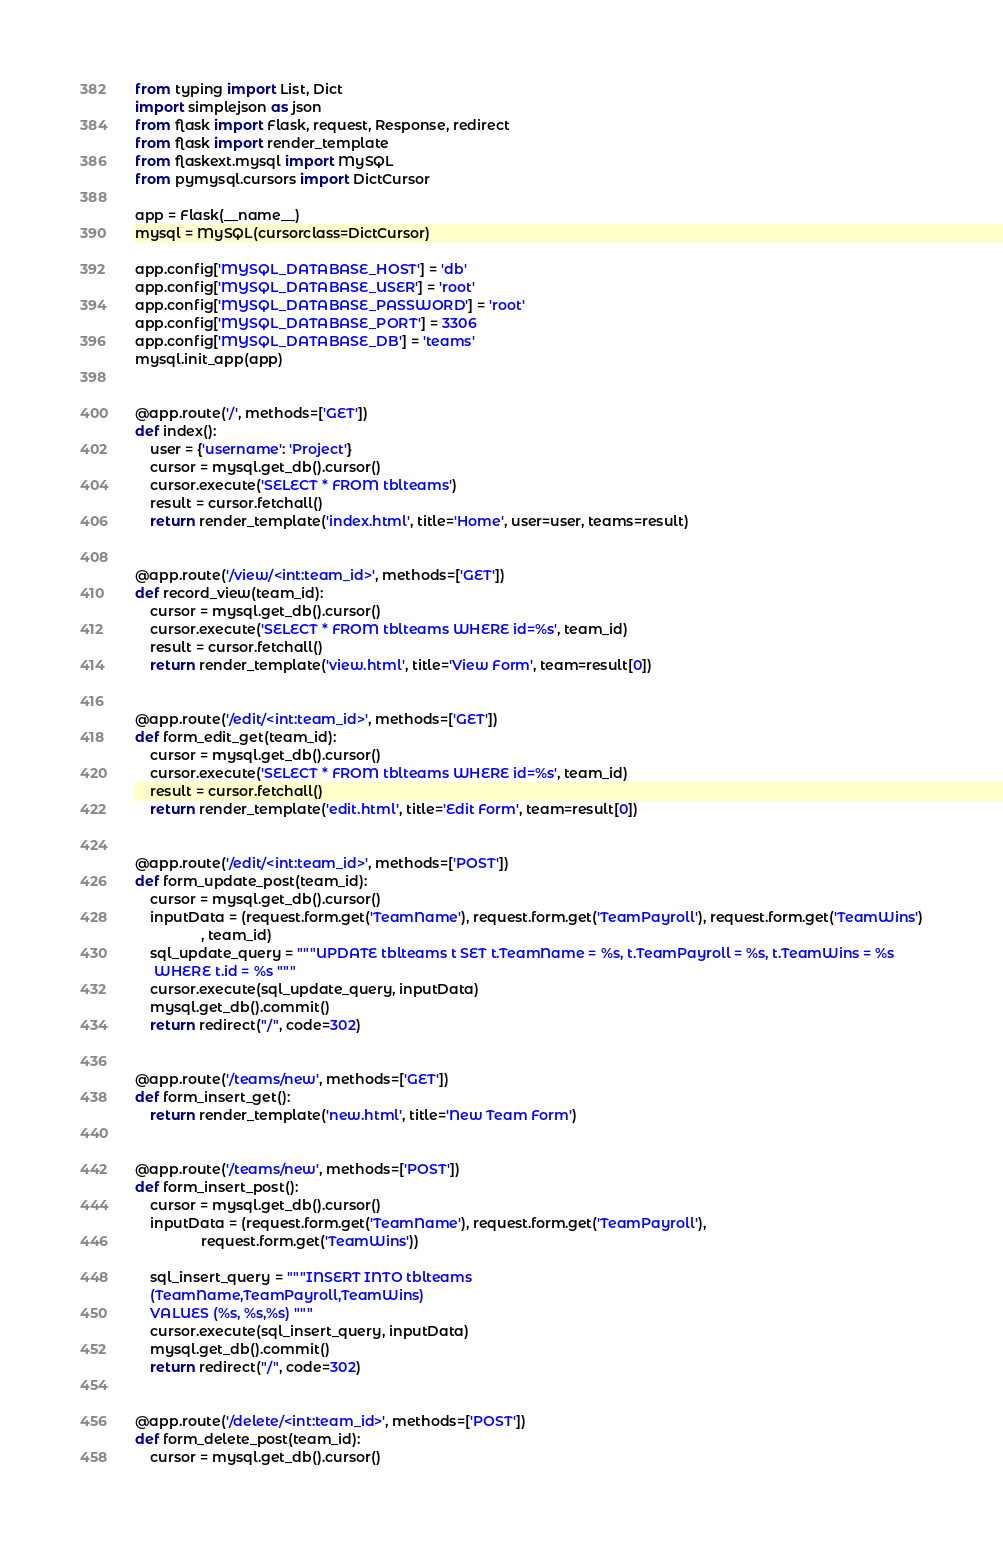Convert code to text. <code><loc_0><loc_0><loc_500><loc_500><_Python_>from typing import List, Dict
import simplejson as json
from flask import Flask, request, Response, redirect
from flask import render_template
from flaskext.mysql import MySQL
from pymysql.cursors import DictCursor

app = Flask(__name__)
mysql = MySQL(cursorclass=DictCursor)

app.config['MYSQL_DATABASE_HOST'] = 'db'
app.config['MYSQL_DATABASE_USER'] = 'root'
app.config['MYSQL_DATABASE_PASSWORD'] = 'root'
app.config['MYSQL_DATABASE_PORT'] = 3306
app.config['MYSQL_DATABASE_DB'] = 'teams'
mysql.init_app(app)


@app.route('/', methods=['GET'])
def index():
    user = {'username': 'Project'}
    cursor = mysql.get_db().cursor()
    cursor.execute('SELECT * FROM tblteams')
    result = cursor.fetchall()
    return render_template('index.html', title='Home', user=user, teams=result)


@app.route('/view/<int:team_id>', methods=['GET'])
def record_view(team_id):
    cursor = mysql.get_db().cursor()
    cursor.execute('SELECT * FROM tblteams WHERE id=%s', team_id)
    result = cursor.fetchall()
    return render_template('view.html', title='View Form', team=result[0])


@app.route('/edit/<int:team_id>', methods=['GET'])
def form_edit_get(team_id):
    cursor = mysql.get_db().cursor()
    cursor.execute('SELECT * FROM tblteams WHERE id=%s', team_id)
    result = cursor.fetchall()
    return render_template('edit.html', title='Edit Form', team=result[0])


@app.route('/edit/<int:team_id>', methods=['POST'])
def form_update_post(team_id):
    cursor = mysql.get_db().cursor()
    inputData = (request.form.get('TeamName'), request.form.get('TeamPayroll'), request.form.get('TeamWins')
                 , team_id)
    sql_update_query = """UPDATE tblteams t SET t.TeamName = %s, t.TeamPayroll = %s, t.TeamWins = %s
     WHERE t.id = %s """
    cursor.execute(sql_update_query, inputData)
    mysql.get_db().commit()
    return redirect("/", code=302)


@app.route('/teams/new', methods=['GET'])
def form_insert_get():
    return render_template('new.html', title='New Team Form')


@app.route('/teams/new', methods=['POST'])
def form_insert_post():
    cursor = mysql.get_db().cursor()
    inputData = (request.form.get('TeamName'), request.form.get('TeamPayroll'),
                 request.form.get('TeamWins'))

    sql_insert_query = """INSERT INTO tblteams 
    (TeamName,TeamPayroll,TeamWins) 
    VALUES (%s, %s,%s) """
    cursor.execute(sql_insert_query, inputData)
    mysql.get_db().commit()
    return redirect("/", code=302)


@app.route('/delete/<int:team_id>', methods=['POST'])
def form_delete_post(team_id):
    cursor = mysql.get_db().cursor()</code> 